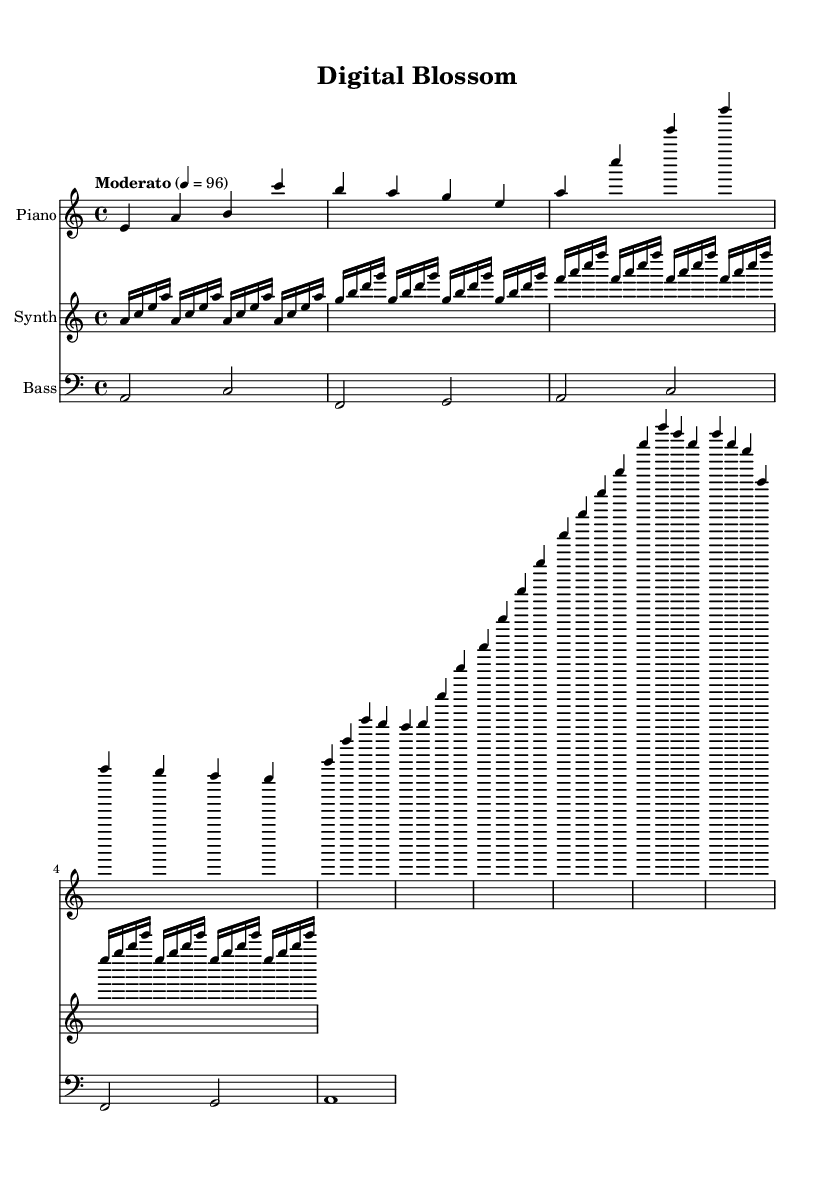What is the key signature of this music? The key signature is A minor, indicated by the presence of a single sharp (G#) in the music, which is common in A minor.
Answer: A minor What is the time signature of this music? The time signature is 4/4, as indicated at the beginning of the music, representing four beats in a measure and a quarter note gets one beat.
Answer: 4/4 What is the tempo marking for this piece? The tempo marking is "Moderato," which suggests a moderate pace for the performance of the music.
Answer: Moderato How many measures are in the piano part? The piano part consists of 9 measures based on counting each individual grouping in the music.
Answer: 9 What type of textures are used throughout the composition? The composition blends organic and digital sounds, utilizing piano, synthesizer, and bass which create a diverse texture typical of experimental instrumental music.
Answer: Blended textures What is the pattern of the synth part during its section? The synth part uses a repeating arpeggio pattern, defined by sequences of notes that are played in a specific order, which gives a sense of continuity.
Answer: Repeating arpeggio Which musical section features the highest pitch notes in the piano part? The chorus section features the highest pitch notes, as evidenced by the ascending sequence in the specified measures.
Answer: Chorus 